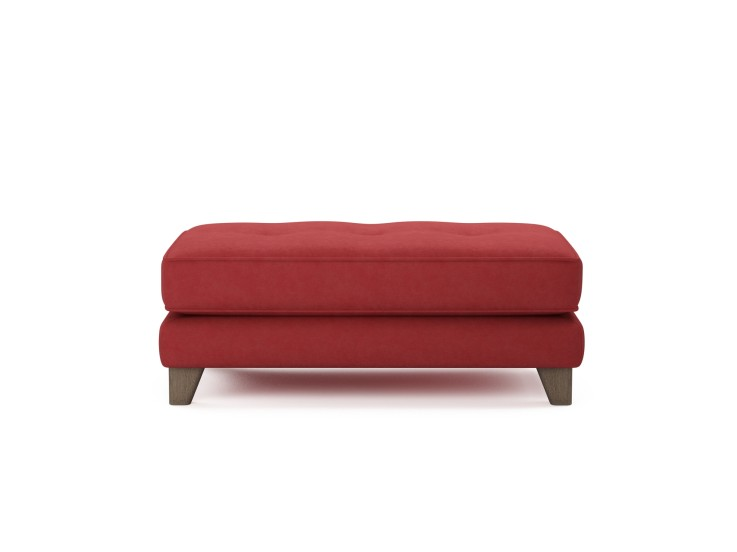Considering the minimalist design of the ottoman, what might be the intended usage environment or aesthetic that this piece of furniture is designed to complement? The ottoman's minimalist design with its smooth, unembellished red fabric and understated wooden legs suggests that it is ideal for modern interior spaces that emphasize a clean and streamlined aesthetic. Places like minimalist living rooms, sleek office lounges, or contemporary art galleries would be greatly complemented by this piece. Its vibrant color can serve as a striking focal point, harmonizing with neutral or monochromatic color schemes to add a touch of warmth and energy. Moreover, its substantial size and padding hint at a functional role for comfortable seating or as a decorative yet practical footrest, merging well within spaces that value both style and utility. 